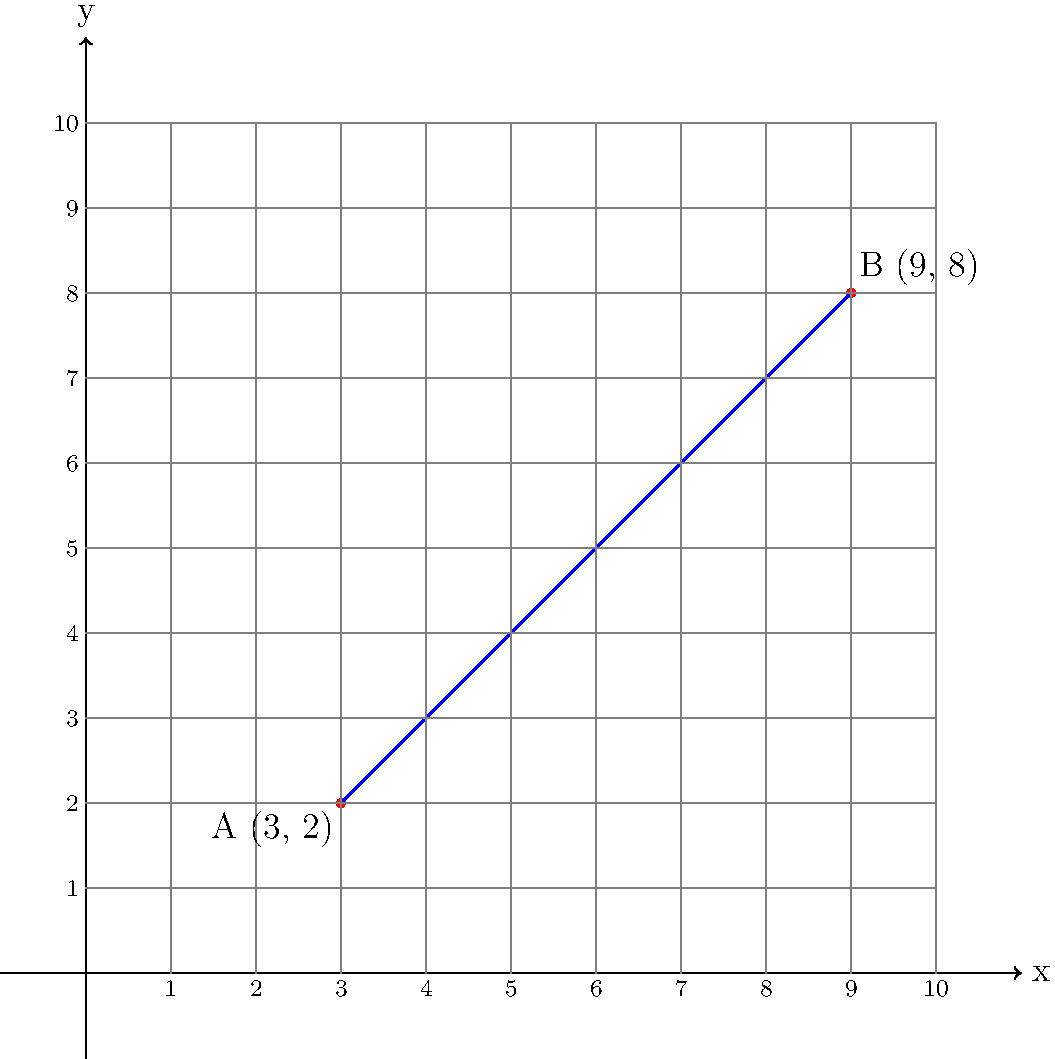During the Napoleonic Wars, two Russian military strongholds are represented on a coordinate grid. Stronghold A is located at (3, 2), and Stronghold B is at (9, 8). Calculate the distance between these two strongholds using the distance formula. Round your answer to the nearest kilometer. To solve this problem, we'll use the distance formula derived from the Pythagorean theorem:

$$d = \sqrt{(x_2 - x_1)^2 + (y_2 - y_1)^2}$$

Where $(x_1, y_1)$ represents the coordinates of the first point and $(x_2, y_2)$ represents the coordinates of the second point.

Step 1: Identify the coordinates
- Stronghold A: $(x_1, y_1) = (3, 2)$
- Stronghold B: $(x_2, y_2) = (9, 8)$

Step 2: Substitute the values into the distance formula
$$d = \sqrt{(9 - 3)^2 + (8 - 2)^2}$$

Step 3: Simplify the expressions inside the parentheses
$$d = \sqrt{6^2 + 6^2}$$

Step 4: Calculate the squares
$$d = \sqrt{36 + 36}$$

Step 5: Add the values under the square root
$$d = \sqrt{72}$$

Step 6: Simplify the square root
$$d = 6\sqrt{2}$$

Step 7: Calculate the approximate value and round to the nearest kilometer
$$d \approx 8.49 \text{ km}$$

Rounding to the nearest kilometer gives us 8 km.
Answer: 8 km 